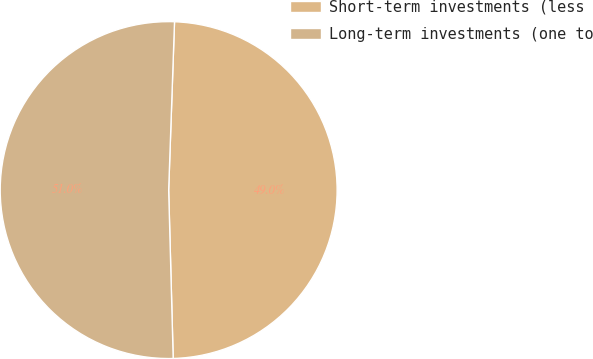Convert chart. <chart><loc_0><loc_0><loc_500><loc_500><pie_chart><fcel>Short-term investments (less<fcel>Long-term investments (one to<nl><fcel>49.02%<fcel>50.98%<nl></chart> 